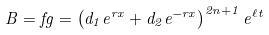<formula> <loc_0><loc_0><loc_500><loc_500>B = f g = \left ( d _ { 1 } e ^ { r x } + d _ { 2 } e ^ { - r x } \right ) ^ { 2 n + 1 } e ^ { \ell t }</formula> 